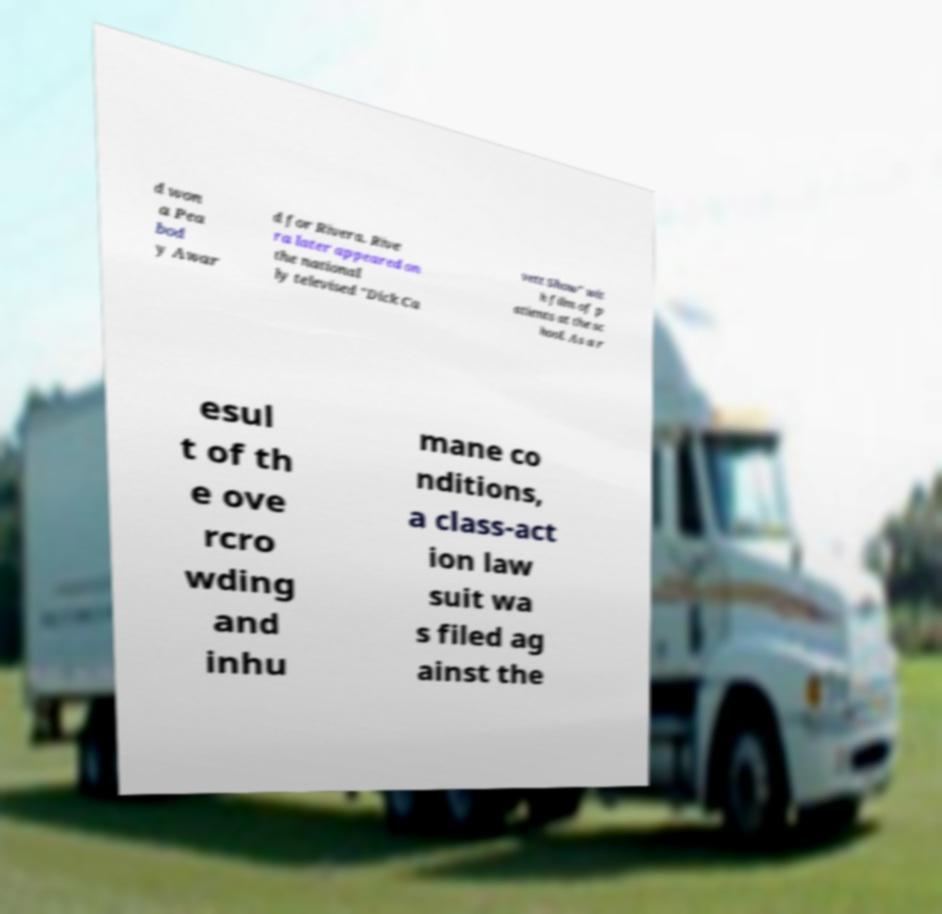For documentation purposes, I need the text within this image transcribed. Could you provide that? d won a Pea bod y Awar d for Rivera. Rive ra later appeared on the national ly televised "Dick Ca vett Show" wit h film of p atients at the sc hool. As a r esul t of th e ove rcro wding and inhu mane co nditions, a class-act ion law suit wa s filed ag ainst the 